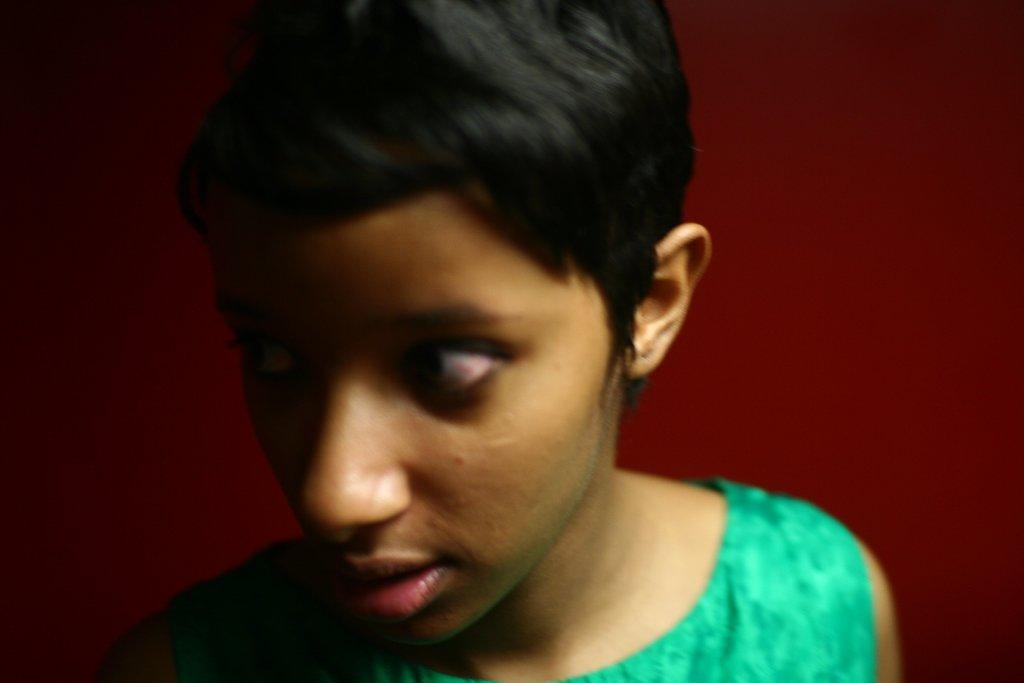Who or what is present in the image? There is a person in the image. What can be seen in the background of the image? There is a wall in the image. How many tickets does the person have in the image? There is no mention of tickets in the image, so it cannot be determined if the person has any. 